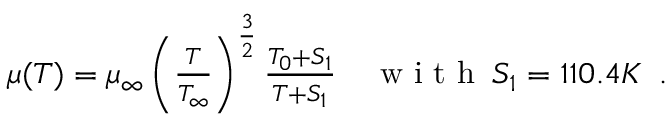<formula> <loc_0><loc_0><loc_500><loc_500>\begin{array} { r l } { \mu ( T ) = \mu _ { \infty } \left ( \frac { T } { T _ { \infty } } \right ) ^ { \frac { 3 } { 2 } } \frac { T _ { 0 } + S _ { 1 } } { T + S _ { 1 } } } & w i t h \, S _ { 1 } = 1 1 0 . 4 K \, . } \end{array}</formula> 